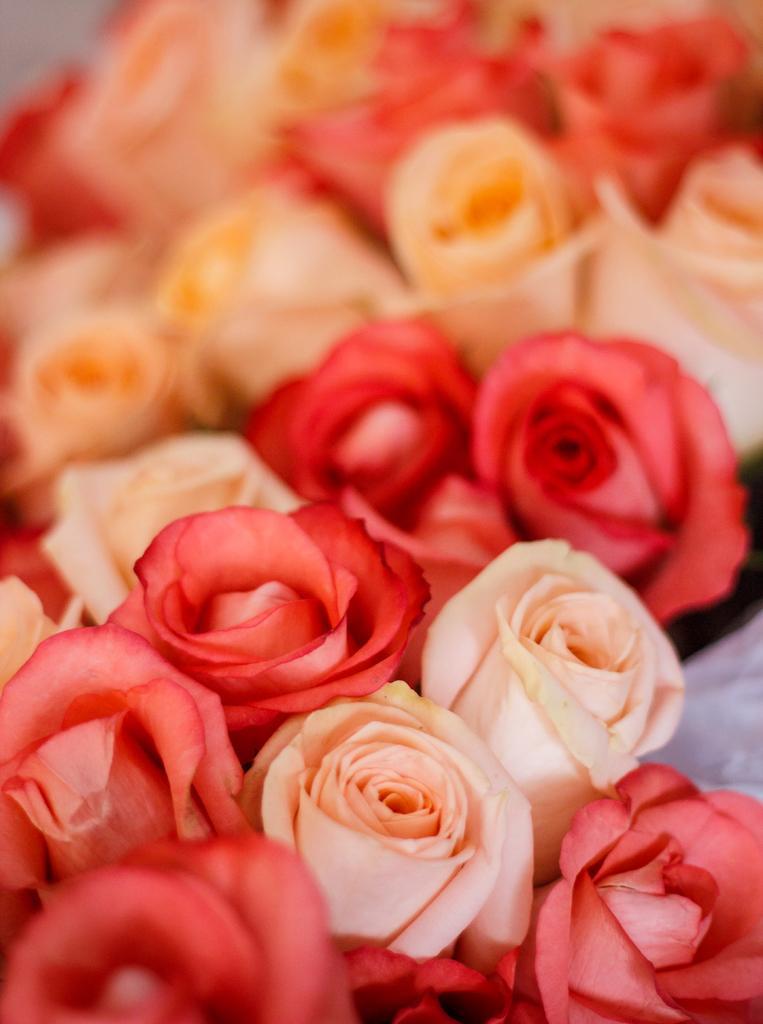In one or two sentences, can you explain what this image depicts? In this image we can see the flowers. 